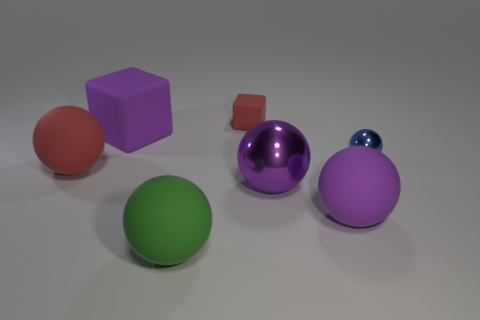Do the big purple object that is to the right of the big metal sphere and the tiny blue object have the same material?
Give a very brief answer. No. What number of other things are the same shape as the big red thing?
Your answer should be very brief. 4. There is a red thing behind the big ball that is on the left side of the green object; how many large purple blocks are on the right side of it?
Make the answer very short. 0. The shiny object that is left of the big purple matte ball is what color?
Make the answer very short. Purple. Is the color of the large rubber sphere on the right side of the green matte thing the same as the big block?
Offer a very short reply. Yes. What size is the blue object that is the same shape as the green rubber thing?
Provide a short and direct response. Small. The tiny thing in front of the block in front of the small red thing that is behind the big green rubber object is made of what material?
Keep it short and to the point. Metal. Is the number of purple shiny balls that are behind the tiny block greater than the number of purple balls that are right of the small blue shiny thing?
Your answer should be very brief. No. Do the red matte sphere and the blue shiny ball have the same size?
Your answer should be very brief. No. What is the color of the tiny thing that is the same shape as the big red rubber object?
Give a very brief answer. Blue. 